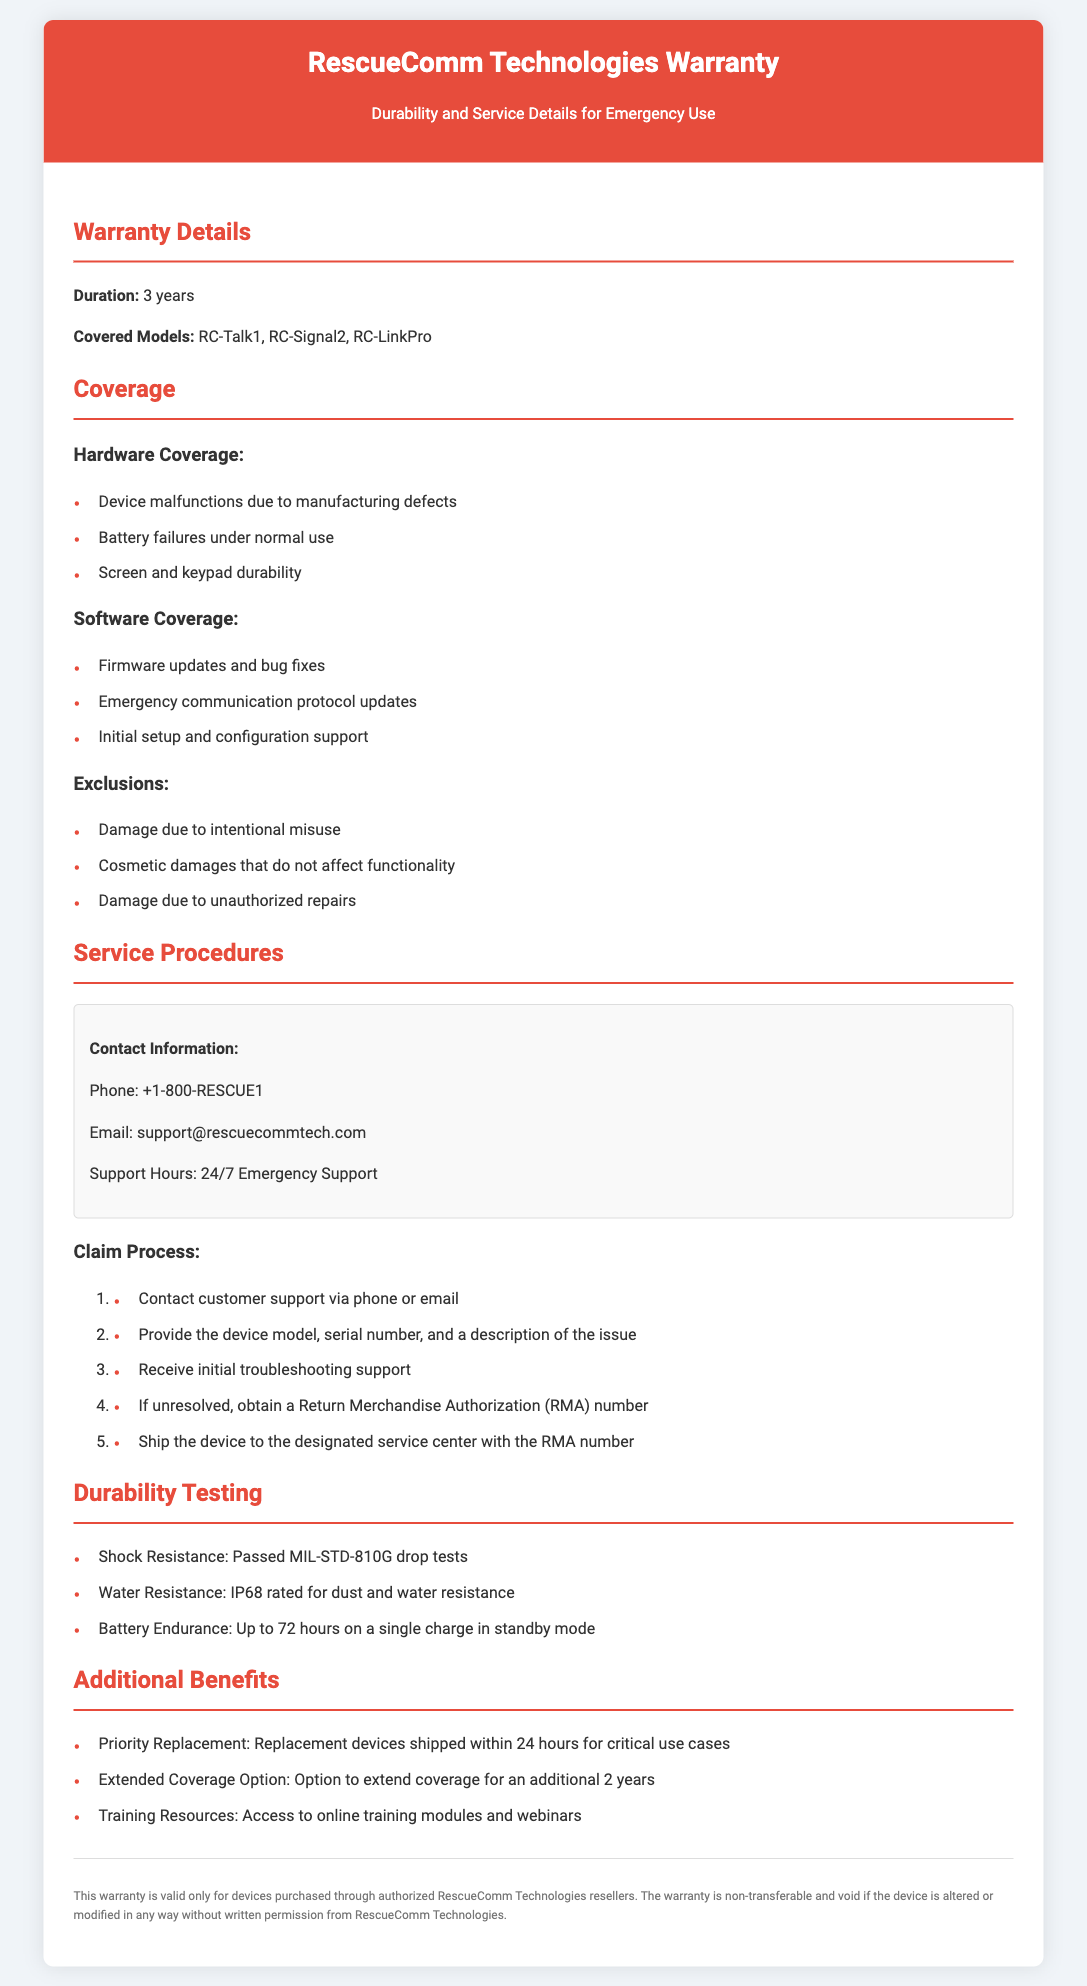What is the warranty duration? The document states that the warranty duration is 3 years.
Answer: 3 years What models are covered under the warranty? The warranty covers the models RC-Talk1, RC-Signal2, and RC-LinkPro.
Answer: RC-Talk1, RC-Signal2, RC-LinkPro What is the battery endurance in standby mode? The document mentions that the battery endurance is up to 72 hours on a single charge in standby mode.
Answer: Up to 72 hours What is excluded from warranty coverage? Damage due to intentional misuse is listed as an exclusion in the warranty coverage.
Answer: Intentional misuse What is required to obtain a Return Merchandise Authorization (RMA) number? To obtain an RMA number, it is necessary to contact customer support and provide the device model, serial number, and a description of the issue.
Answer: Contact customer support What testing standard does the device pass for shock resistance? The document indicates the devices passed MIL-STD-810G drop tests for shock resistance.
Answer: MIL-STD-810G How quickly are replacement devices shipped for critical use cases? The warranty mentions that replacement devices are shipped within 24 hours for critical use cases.
Answer: Within 24 hours What support hours are provided for customer service? The customer support hours are specified as 24/7 Emergency Support in the document.
Answer: 24/7 Emergency Support 